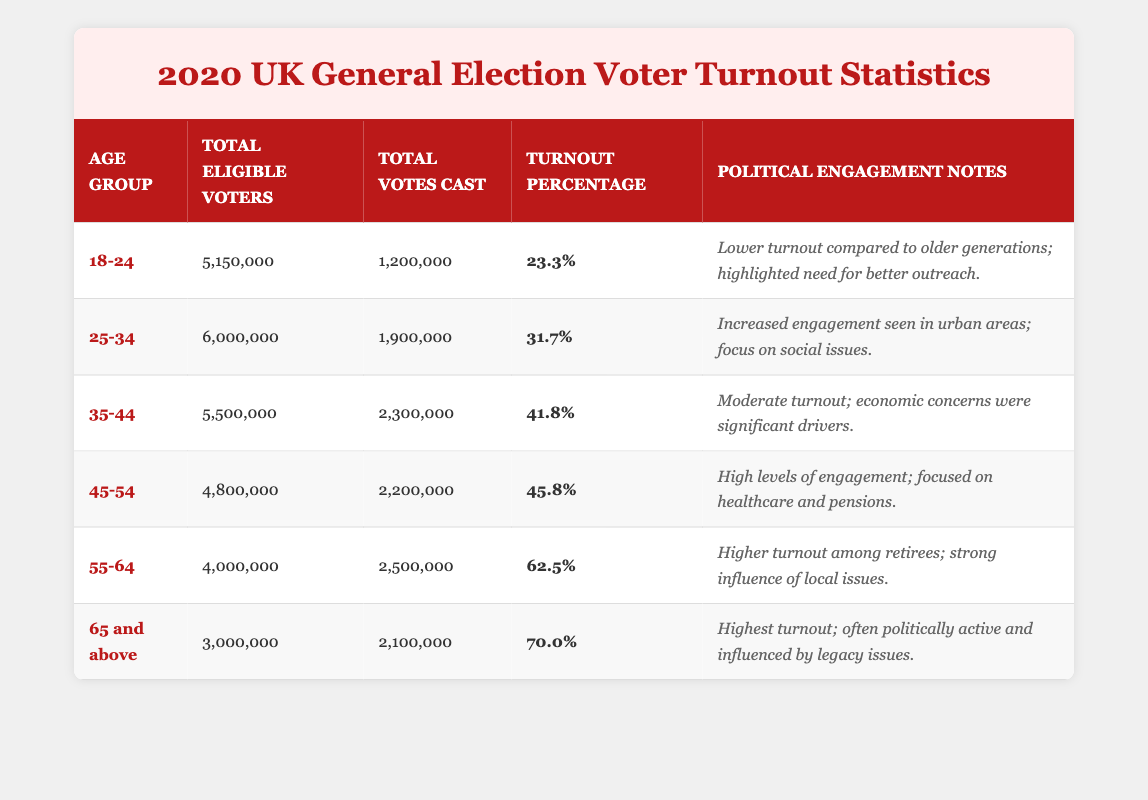What was the turnout percentage for the 45-54 age group? The turnout percentage for the 45-54 age group is listed directly in the table under the relevant column, which shows it as 45.8%.
Answer: 45.8% How many total eligible voters were there in the 18-24 age group? The total eligible voters for the 18-24 age group can be found in the corresponding row of the table, which states there were 5,150,000 eligible voters.
Answer: 5,150,000 What is the difference in turnout percentage between the 55-64 and 35-44 age groups? The turnout percentage for the 55-64 age group is 62.5%, and for the 35-44 group, it is 41.8%. The difference is calculated as 62.5% - 41.8% = 20.7%.
Answer: 20.7% Is it true that the age group with the highest eligible voters is the 25-34 group? By reviewing the table, the 25-34 age group has 6,000,000 eligible voters, but the 18-24 group has 5,150,000, the 35-44 group has 5,500,000, the 45-54 group has 4,800,000, the 55-64 group has 4,000,000, and the 65 and above group has 3,000,000. Therefore, the 25-34 group does not have the highest; it is actually the 25-34 group.
Answer: False What is the average turnout percentage for all age groups combined? To find the average turnout percentage, first sum all the percentages: 23.3 + 31.7 + 41.8 + 45.8 + 62.5 + 70.0 = 275.1. Then divide by the number of age groups, which is 6: 275.1 / 6 = 45.85.
Answer: 45.85 